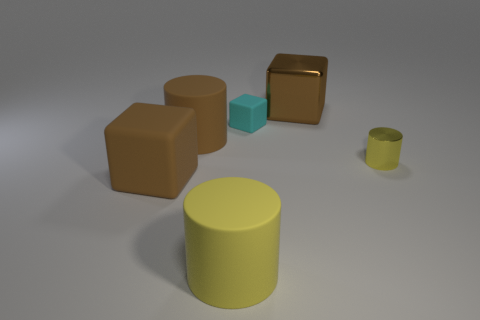Add 1 big blocks. How many objects exist? 7 Add 5 brown metal things. How many brown metal things are left? 6 Add 5 small brown cylinders. How many small brown cylinders exist? 5 Subtract 0 purple blocks. How many objects are left? 6 Subtract all cyan matte cubes. Subtract all big brown rubber cylinders. How many objects are left? 4 